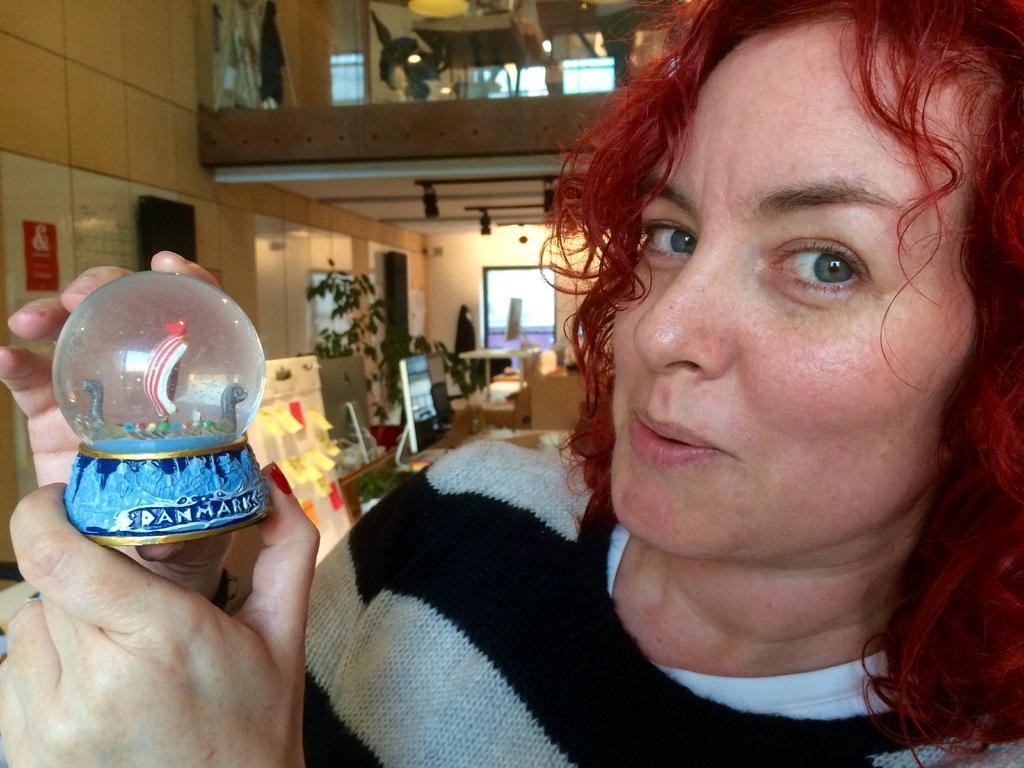How would you summarize this image in a sentence or two? In the front of the image I can see a woman is holding an object. In the background of the image there are plants, boards, monitors, tables, posters, sticky notes, wall, lights and objects. 